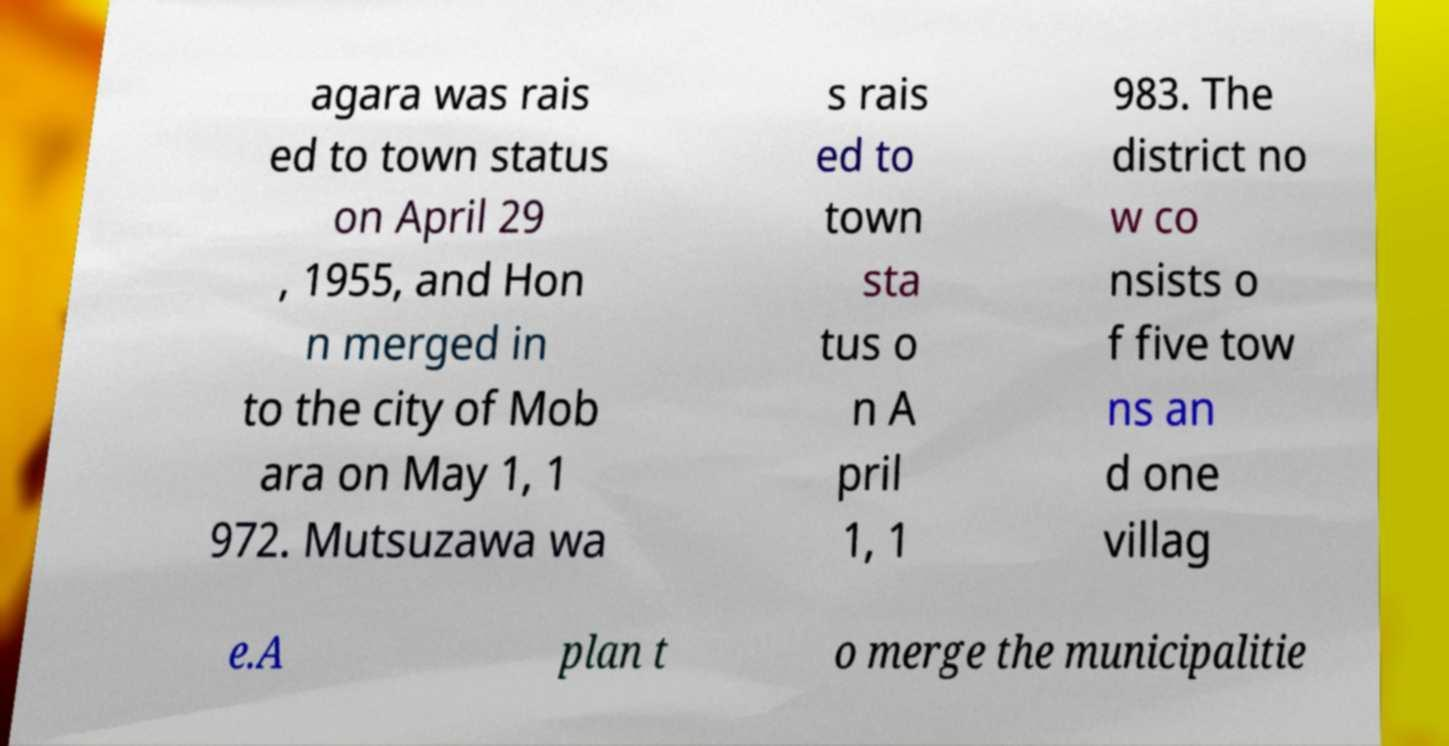Please identify and transcribe the text found in this image. agara was rais ed to town status on April 29 , 1955, and Hon n merged in to the city of Mob ara on May 1, 1 972. Mutsuzawa wa s rais ed to town sta tus o n A pril 1, 1 983. The district no w co nsists o f five tow ns an d one villag e.A plan t o merge the municipalitie 